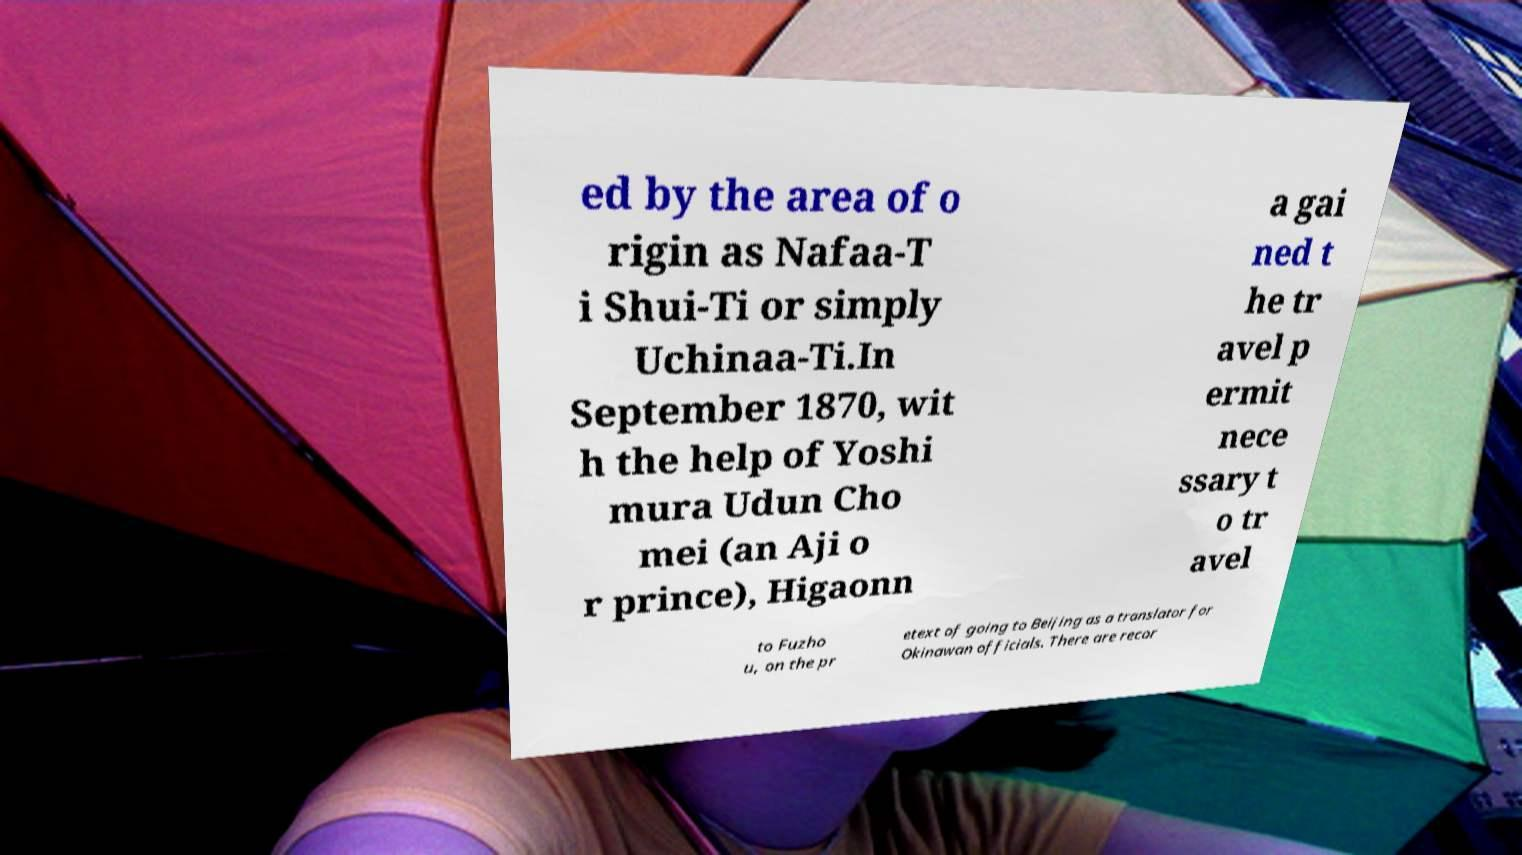I need the written content from this picture converted into text. Can you do that? ed by the area of o rigin as Nafaa-T i Shui-Ti or simply Uchinaa-Ti.In September 1870, wit h the help of Yoshi mura Udun Cho mei (an Aji o r prince), Higaonn a gai ned t he tr avel p ermit nece ssary t o tr avel to Fuzho u, on the pr etext of going to Beijing as a translator for Okinawan officials. There are recor 